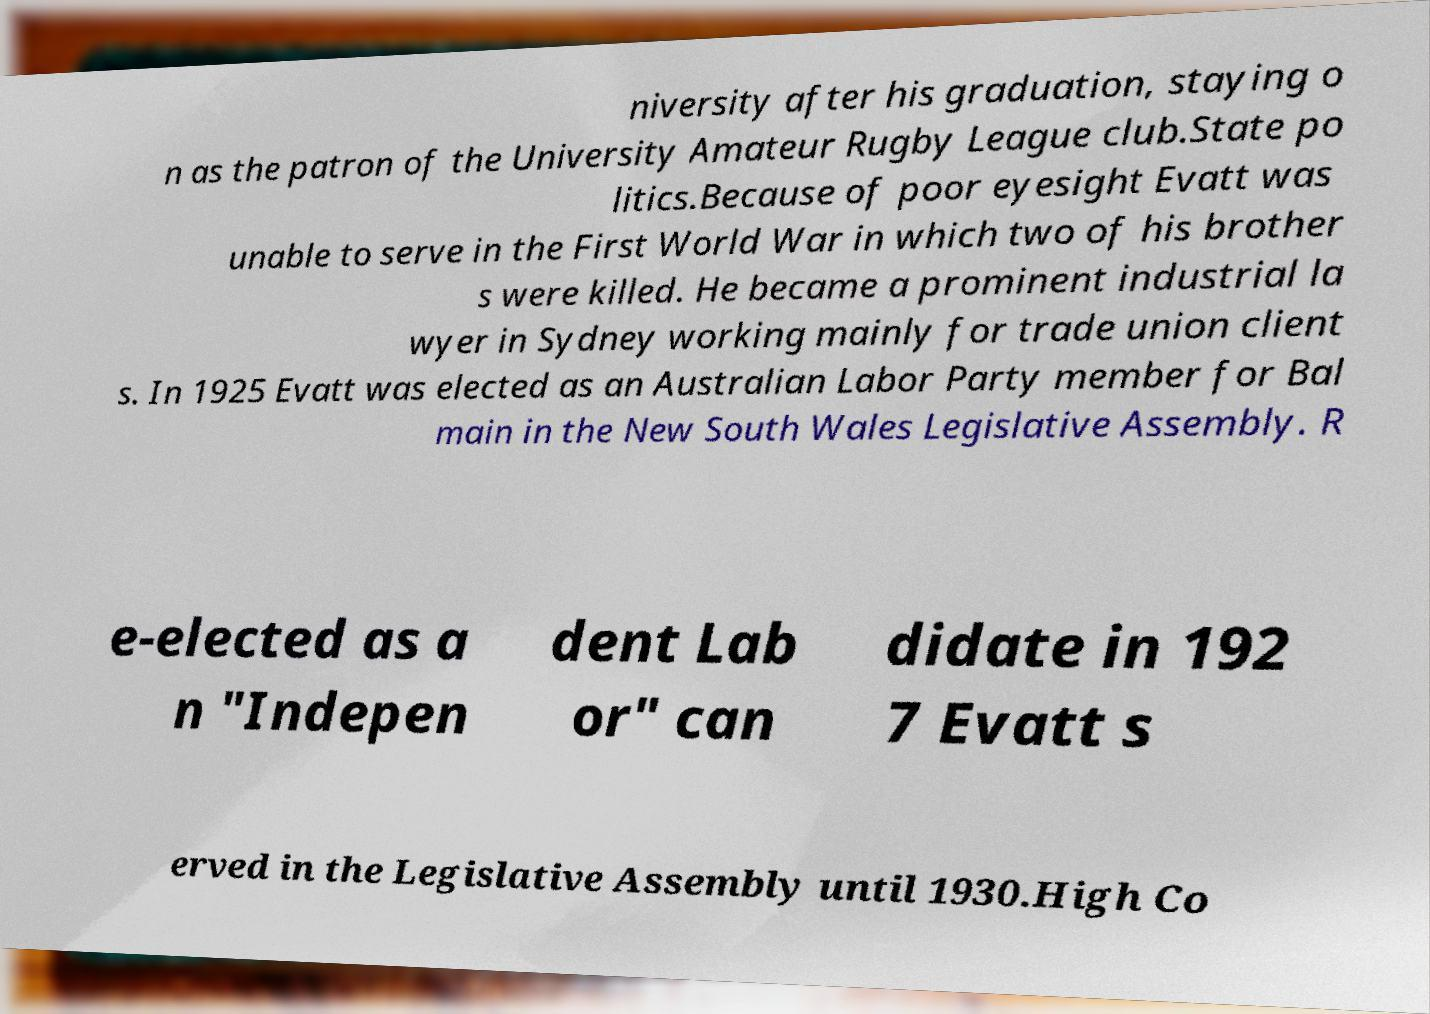Can you accurately transcribe the text from the provided image for me? niversity after his graduation, staying o n as the patron of the University Amateur Rugby League club.State po litics.Because of poor eyesight Evatt was unable to serve in the First World War in which two of his brother s were killed. He became a prominent industrial la wyer in Sydney working mainly for trade union client s. In 1925 Evatt was elected as an Australian Labor Party member for Bal main in the New South Wales Legislative Assembly. R e-elected as a n "Indepen dent Lab or" can didate in 192 7 Evatt s erved in the Legislative Assembly until 1930.High Co 